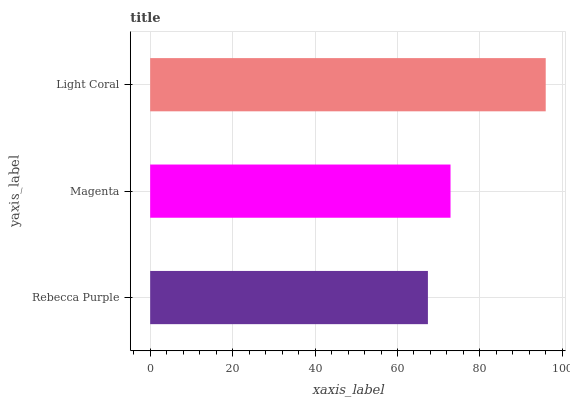Is Rebecca Purple the minimum?
Answer yes or no. Yes. Is Light Coral the maximum?
Answer yes or no. Yes. Is Magenta the minimum?
Answer yes or no. No. Is Magenta the maximum?
Answer yes or no. No. Is Magenta greater than Rebecca Purple?
Answer yes or no. Yes. Is Rebecca Purple less than Magenta?
Answer yes or no. Yes. Is Rebecca Purple greater than Magenta?
Answer yes or no. No. Is Magenta less than Rebecca Purple?
Answer yes or no. No. Is Magenta the high median?
Answer yes or no. Yes. Is Magenta the low median?
Answer yes or no. Yes. Is Rebecca Purple the high median?
Answer yes or no. No. Is Rebecca Purple the low median?
Answer yes or no. No. 